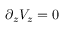Convert formula to latex. <formula><loc_0><loc_0><loc_500><loc_500>\partial _ { z } V _ { z } = 0</formula> 